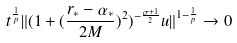Convert formula to latex. <formula><loc_0><loc_0><loc_500><loc_500>t ^ { \frac { 1 } { p } } \| ( 1 + ( \frac { r _ { * } - \alpha _ { * } } { 2 M } ) ^ { 2 } ) ^ { - \frac { \sigma + 1 } { 2 } } u \| ^ { 1 - \frac { 1 } { p } } \rightarrow 0</formula> 